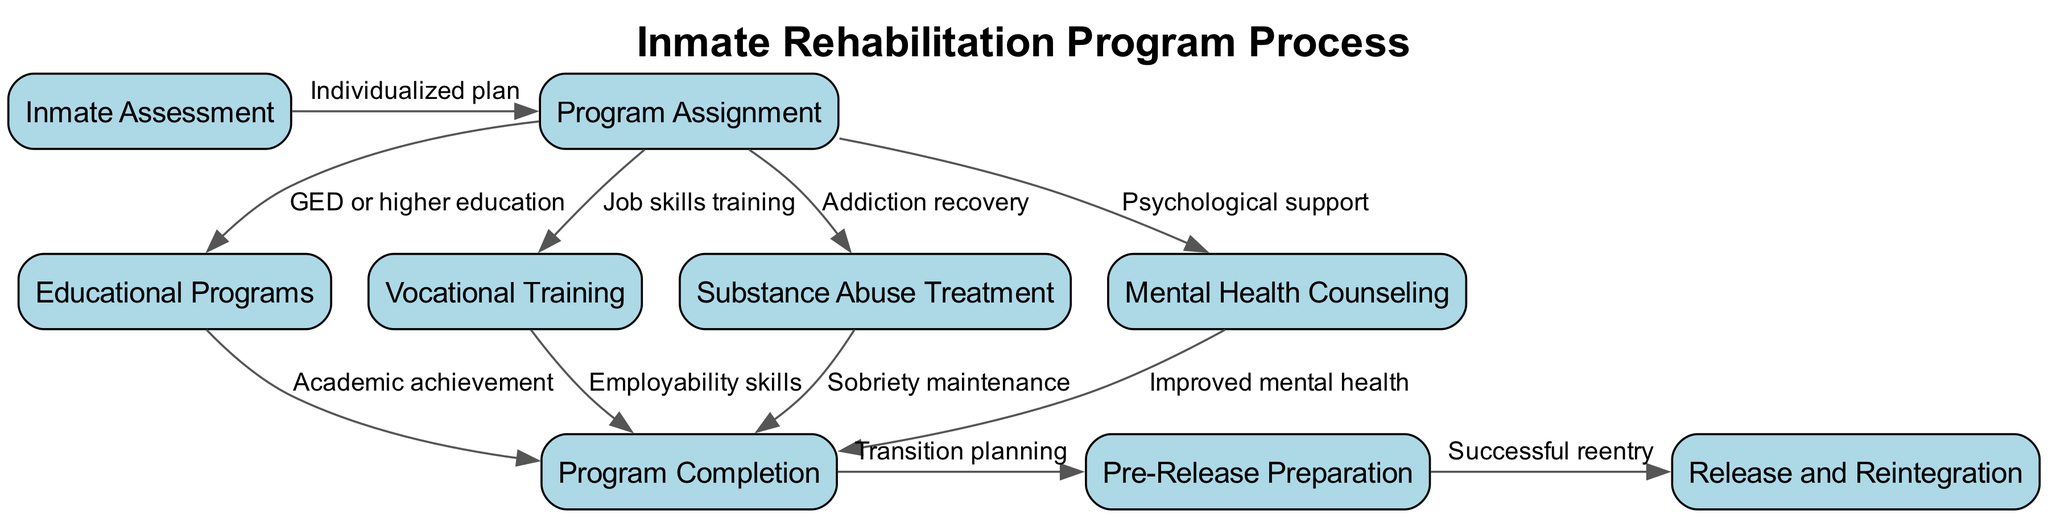What is the first step in the rehabilitation program? The diagram indicates that the first step is "Inmate Assessment," which is clearly marked as the starting node.
Answer: Inmate Assessment How many nodes are in the diagram? By counting all the unique nodes listed in the diagram, there are a total of 9 nodes that represent different stages in the rehabilitation process.
Answer: 9 What type of program follows "Program Assignment"? The diagram shows that after "Program Assignment," the inmate can enter various programs, specifically "Educational Programs," "Vocational Training," "Substance Abuse Treatment," or "Mental Health Counseling," but does not indicate a singular follow-up program.
Answer: Educational Programs, Vocational Training, Substance Abuse Treatment, Mental Health Counseling Which outcome follows after "Program Completion"? Looking at the diagram, "Program Completion" leads to "Pre-Release Preparation," which indicates the transition stage before the inmate is released.
Answer: Pre-Release Preparation What outcome is associated with "Job skills training"? The flowchart states that "Job skills training," which is part of "Vocational Training," results in "Employability skills," signifying that as a result of this program, inmates gain skills useful for finding jobs.
Answer: Employability skills How does "Substance Abuse Treatment" contribute to the rehabilitation process? The diagram illustrates that "Substance Abuse Treatment" leads to "Sobriety maintenance," indicating that this program aims to help inmates maintain sobriety as part of their rehabilitation.
Answer: Sobriety maintenance What is the final stage of the rehabilitation program? The last node in the flowchart, which signifies the conclusion of the rehabilitation process, leads to "Release and Reintegration." This is the point where inmates exit the correctional facility and re-enter society.
Answer: Release and Reintegration What process occurs after "Pre-Release Preparation"? According to the diagram, "Pre-Release Preparation" leads to "Successful reentry," which indicates the culmination of the rehabilitation efforts as inmates move back into the community.
Answer: Successful reentry What does "Improved mental health" stem from? The diagram connects "Improved mental health" to the node "Mental Health Counseling," indicating that this program specifically addresses and aims to enhance the mental well-being of inmates.
Answer: Mental Health Counseling 